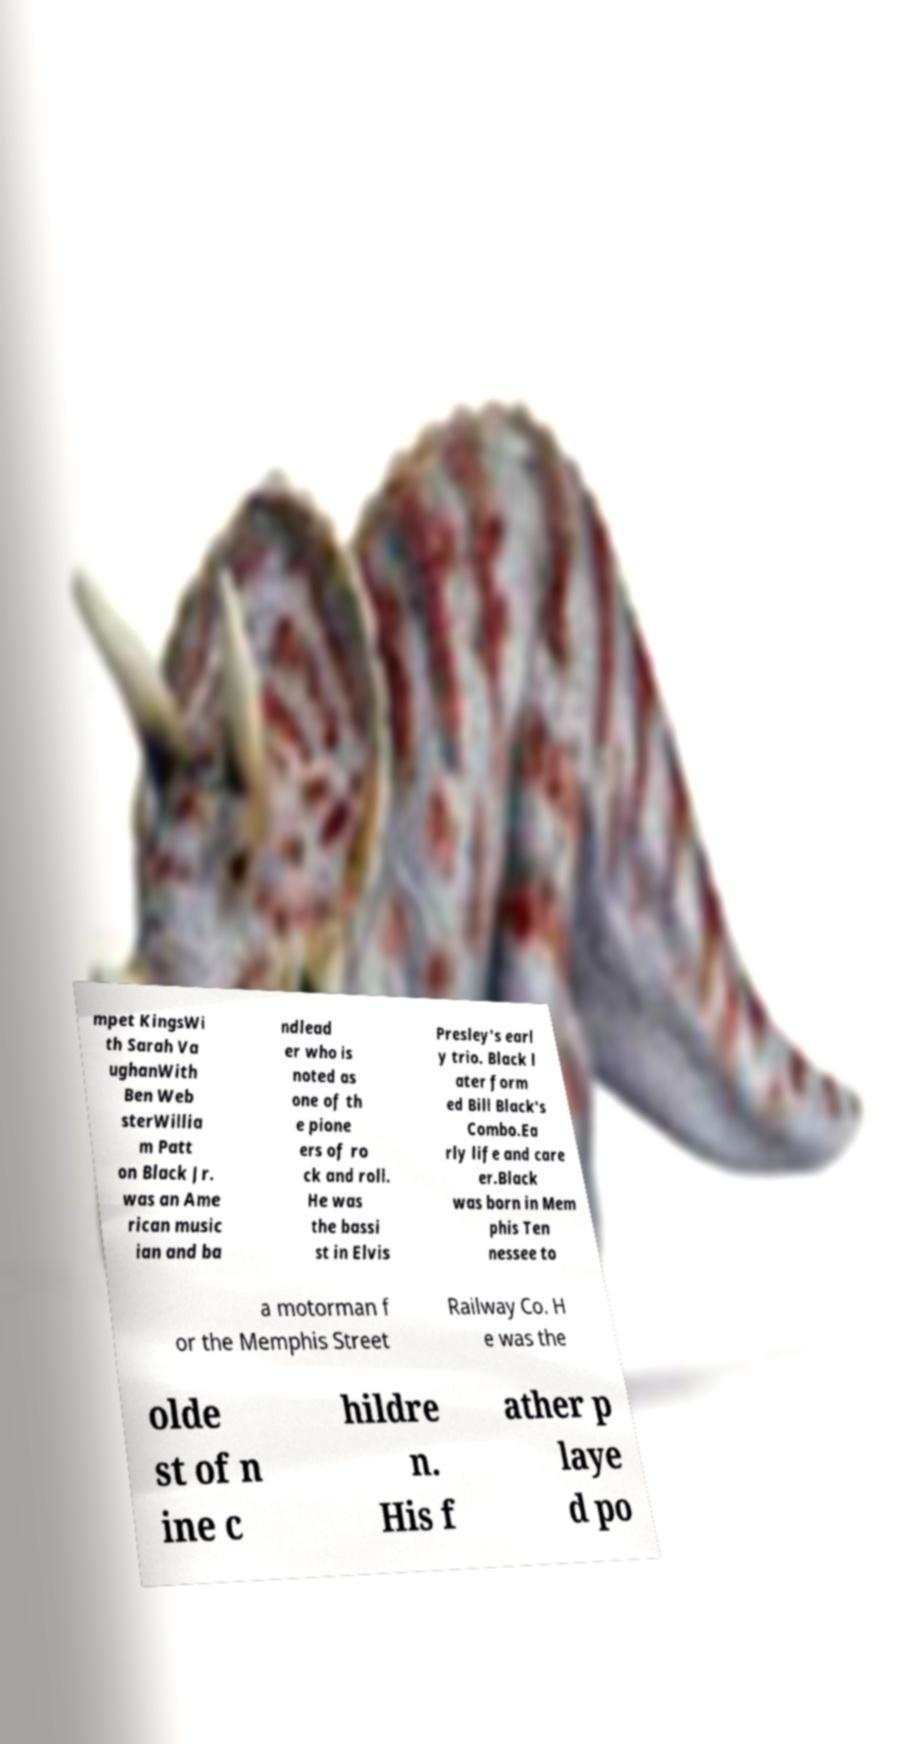What messages or text are displayed in this image? I need them in a readable, typed format. mpet KingsWi th Sarah Va ughanWith Ben Web sterWillia m Patt on Black Jr. was an Ame rican music ian and ba ndlead er who is noted as one of th e pione ers of ro ck and roll. He was the bassi st in Elvis Presley's earl y trio. Black l ater form ed Bill Black's Combo.Ea rly life and care er.Black was born in Mem phis Ten nessee to a motorman f or the Memphis Street Railway Co. H e was the olde st of n ine c hildre n. His f ather p laye d po 